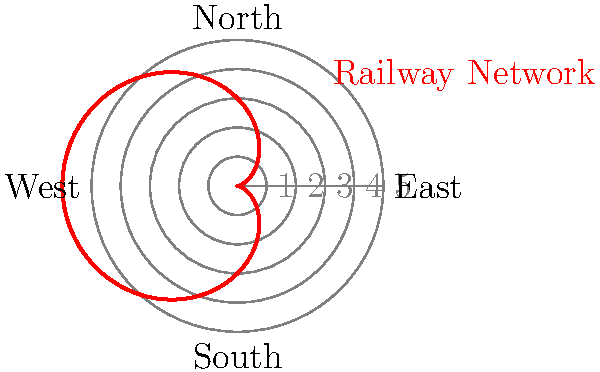The polar graph shown represents the spread of railway networks across a country during the Industrial Revolution. The equation of the curve is given by $r = a(1-\cos(\theta))$, where $a$ is a constant. If the maximum radius of the network is 6 units, what is the value of $a$? To solve this problem, let's follow these steps:

1) The equation of the curve is given by $r = a(1-\cos(\theta))$.

2) The maximum radius occurs when $\cos(\theta) = -1$, which happens when $\theta = \pi$ (or 180 degrees).

3) At this point, the radius is at its maximum value of 6 units. We can express this as:

   $6 = a(1-\cos(\pi))$

4) We know that $\cos(\pi) = -1$, so we can simplify:

   $6 = a(1-(-1)) = a(2)$

5) Solving for $a$:

   $a = 6/2 = 3$

Therefore, the value of the constant $a$ is 3.

This result shows that the railway network expanded to a maximum distance of twice the value of $a$ from the origin, illustrating the significant geographical reach of the industrial revolution's infrastructure development.
Answer: $a = 3$ 